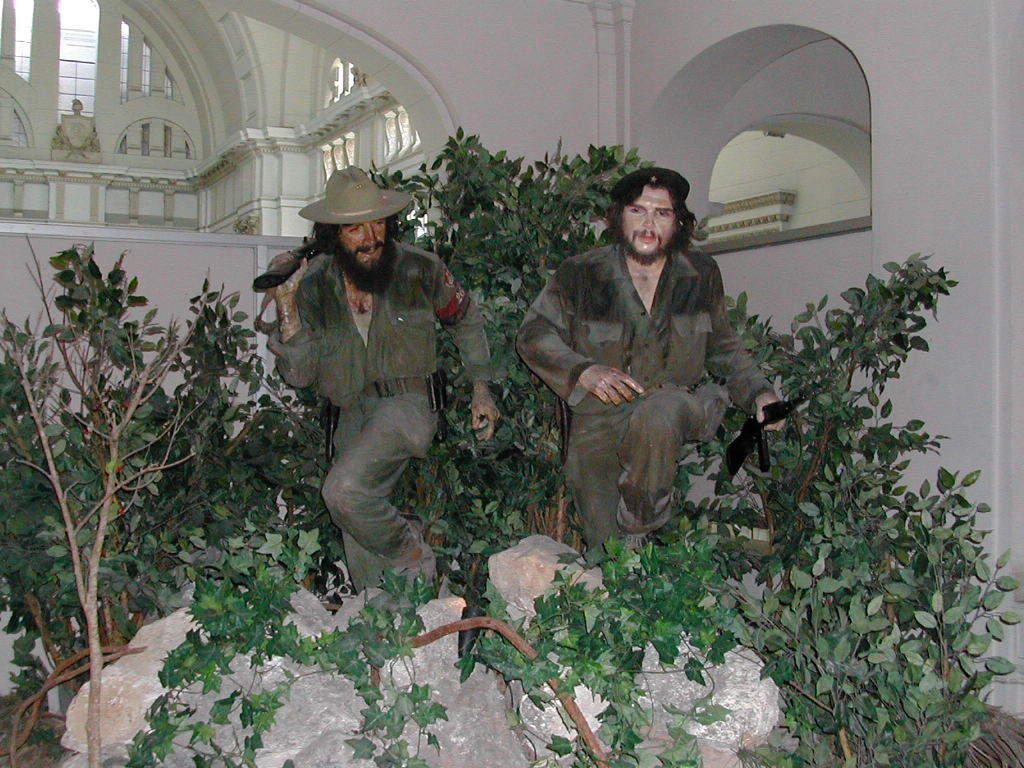Please provide a concise description of this image. In this image, we can see statues in front of the wall. There are some plants in the middle of the image. There are rocks at the bottom of the image. 